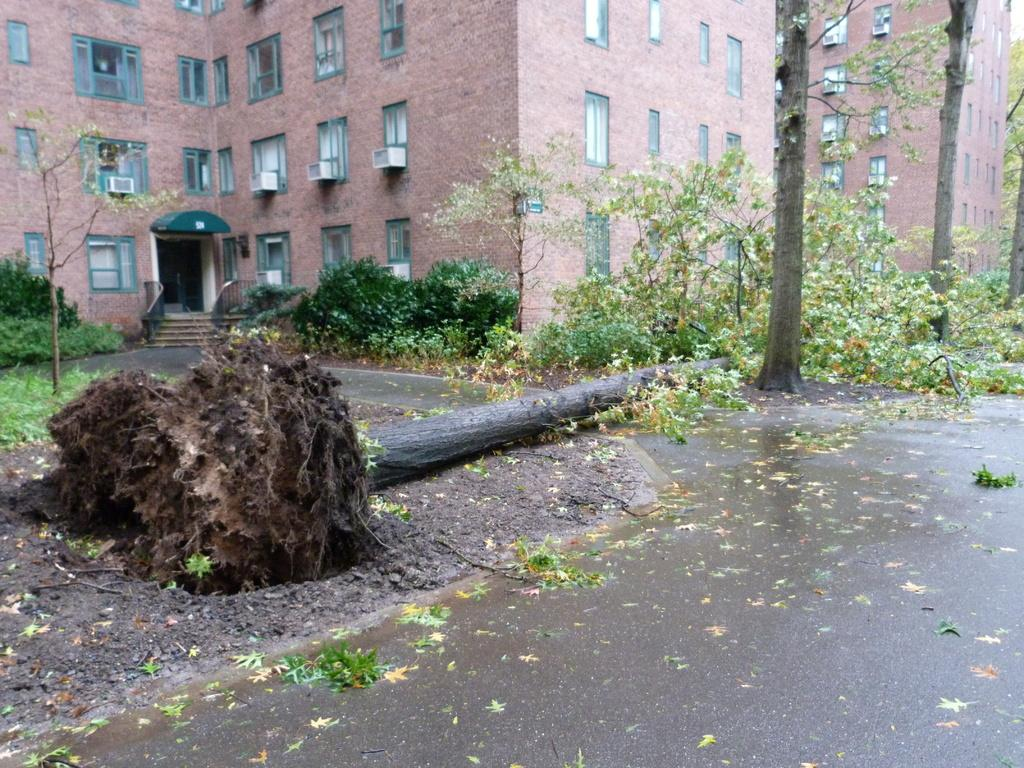What is on the ground in the image? There is a fallen tree on the ground in the image. What can be seen in the distance in the image? There are buildings, trees, plants, and grass visible in the background of the image. Are there any leaves on the ground in the image? Yes, there are leaves on the road in the background of the image. What type of wax is being used to support the belief of the fallen tree in the image? There is no wax or belief mentioned in the image; it simply shows a fallen tree on the ground and other elements in the background. 